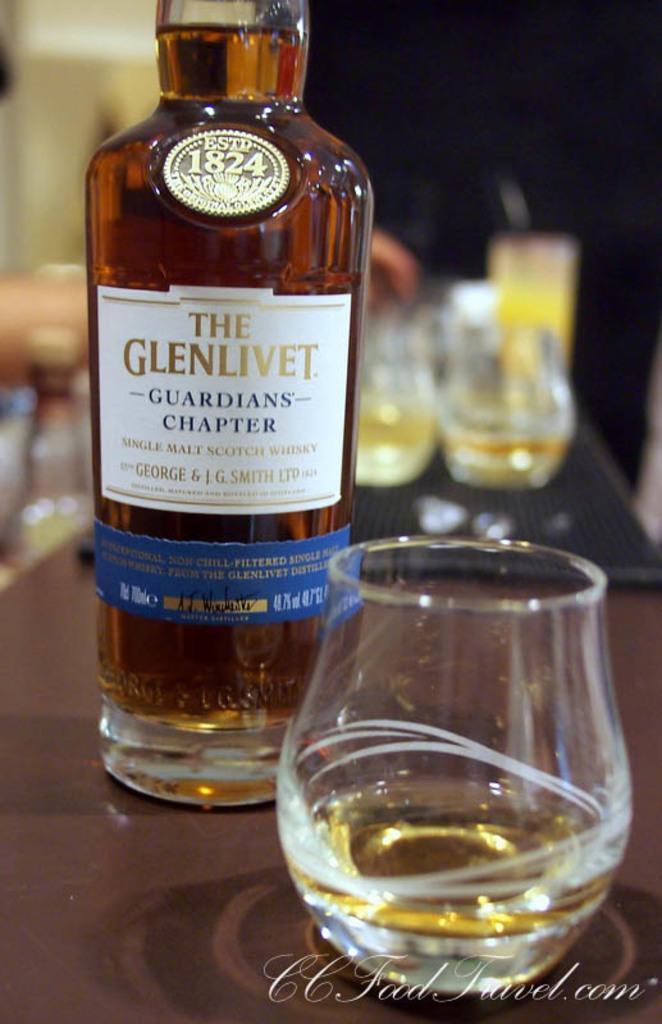<image>
Write a terse but informative summary of the picture. A magazine ad for Glenlivet Scotch Whisky showing the impressive bottle standing next to a whisky tumbler. 